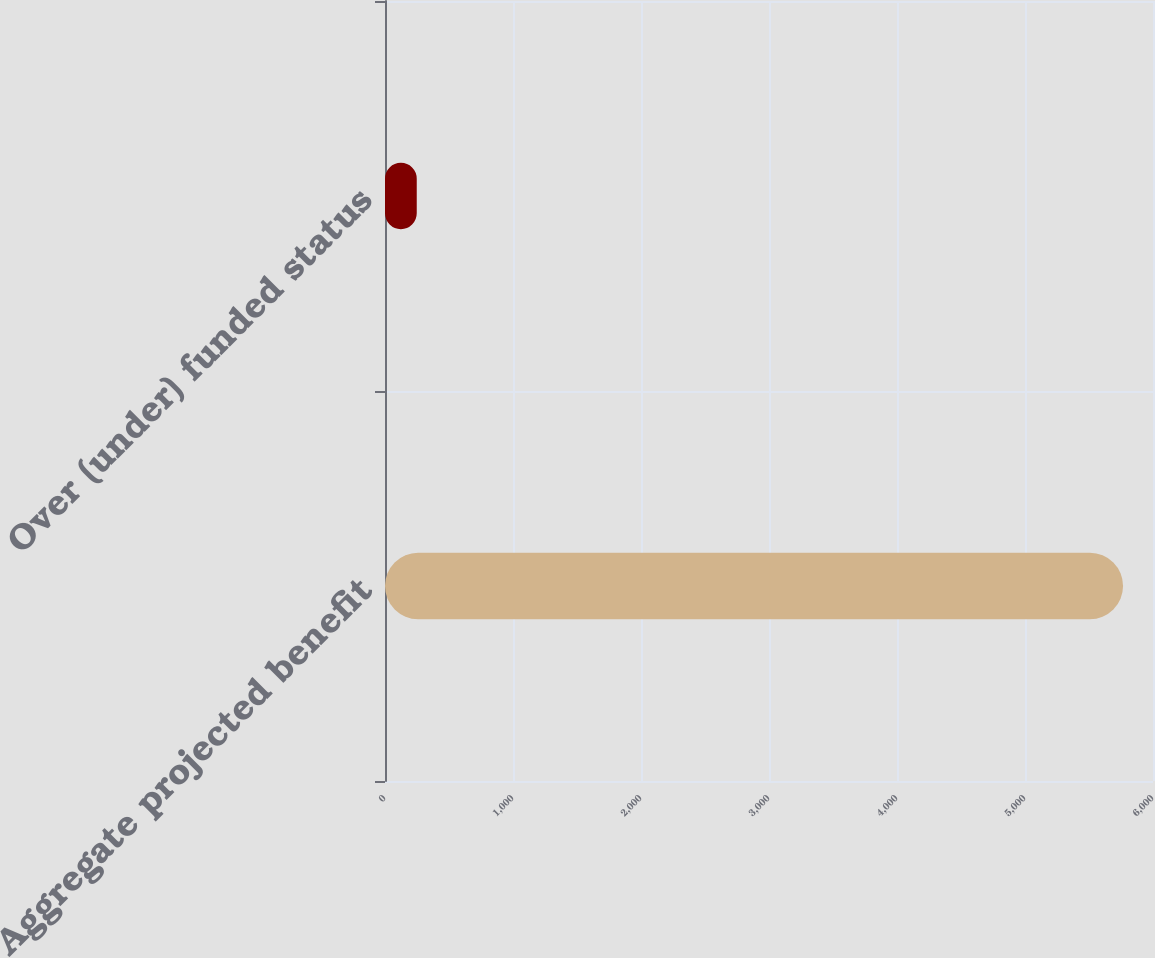Convert chart. <chart><loc_0><loc_0><loc_500><loc_500><bar_chart><fcel>Aggregate projected benefit<fcel>Over (under) funded status<nl><fcel>5766<fcel>248<nl></chart> 